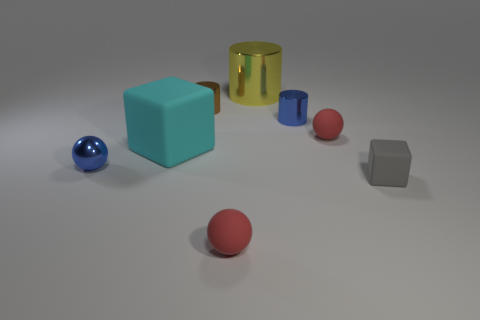Add 2 cyan blocks. How many objects exist? 10 Subtract all blocks. How many objects are left? 6 Subtract 1 blue balls. How many objects are left? 7 Subtract all small gray cubes. Subtract all brown things. How many objects are left? 6 Add 3 blue cylinders. How many blue cylinders are left? 4 Add 6 tiny yellow cubes. How many tiny yellow cubes exist? 6 